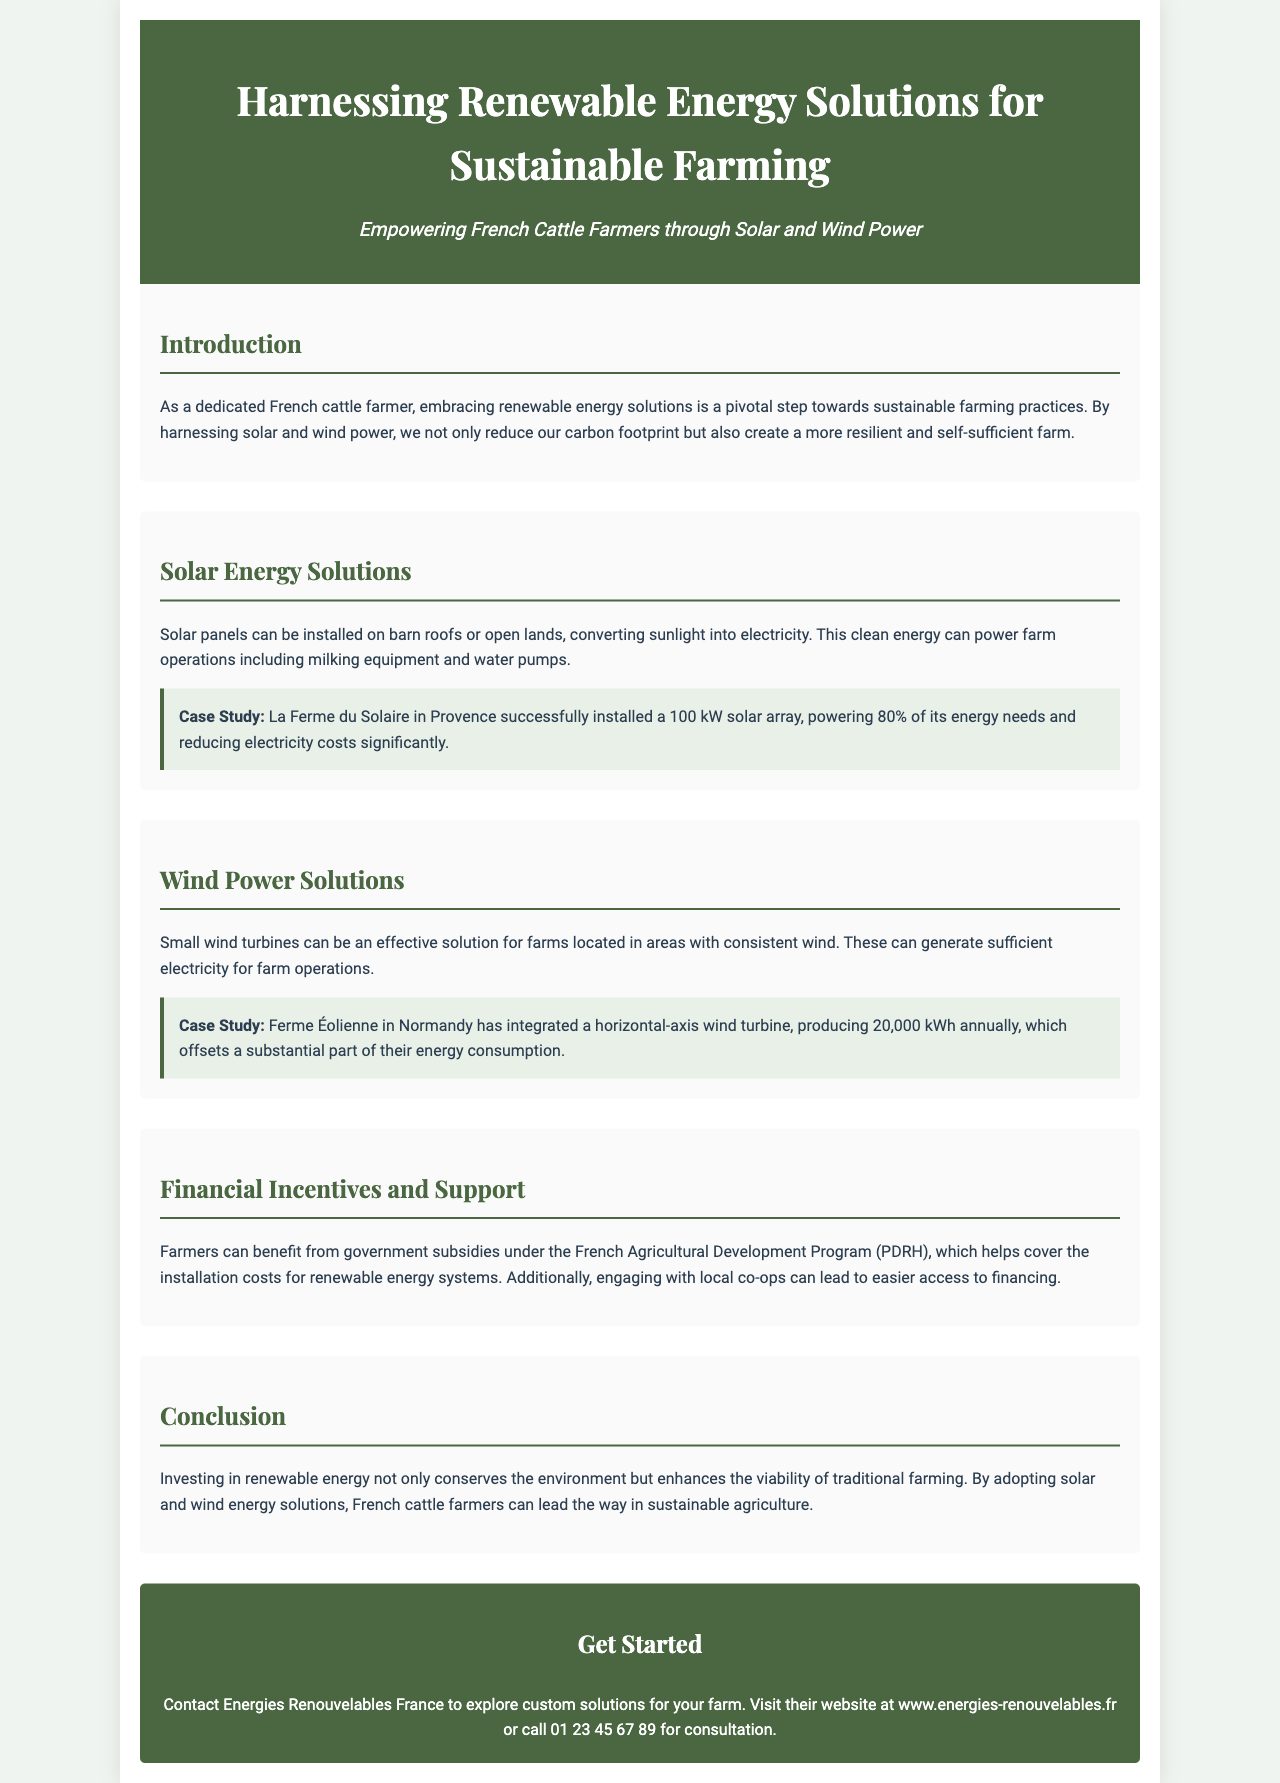Quels sont les deux types d'énergie renouvelable mentionnés ? Les deux types d'énergie renouvelable mentionnés dans le document sont l'énergie solaire et l'énergie éolienne.
Answer: Énergie solaire et éolienne Quel est le pourcentage des besoins énergétiques couverts par La Ferme du Solaire ? La Ferme du Solaire a réussi à couvrir 80% de ses besoins énergétiques grâce à l'installation de panneaux solaires.
Answer: 80% Quel est le nom du programme d'aide pour les agriculteurs en France ? Le programme d'aide mentionné pour les agriculteurs est le Programme de Développement Rural Français (PDRH).
Answer: PDRH Quelle est la production annuelle en kWh de la Ferme Éolienne ? La Ferme Éolienne produit 20 000 kWh par an grâce à son éolienne à axe horizontal.
Answer: 20 000 kWh Quelle solution d'énergie renouvelable est suggérée pour les fermes avec un vent constant ? Le document recommande d'installer des petites éoliennes pour les fermes situées dans des zones avec un vent constant.
Answer: Petites éoliennes Quel organisme est mentionné pour aider les fermiers à explorer des solutions personnalisées ? Energies Renouvelables France est l'organisme mentionné pour aider les fermiers à explorer des solutions personnalisées.
Answer: Energies Renouvelables France Comment le document décrit-il l'impact de l'investissement dans les énergies renouvelables sur les fermes traditionnelles ? L'investissement dans les énergies renouvelables est décrit comme améliorant la viabilité de l'agriculture traditionnelle.
Answer: Améliore la viabilité Quel est le rôle des coopératives locales selon le document ? Les coopératives locales peuvent faciliter l'accès au financement pour les agriculteurs.
Answer: Accès au financement 